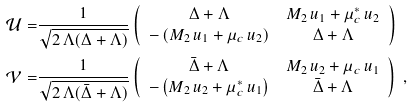<formula> <loc_0><loc_0><loc_500><loc_500>\mathcal { U } = & \frac { 1 } { \sqrt { 2 \, \Lambda ( \Delta + \Lambda ) } } \left ( \begin{array} { c c } \Delta + \Lambda & M _ { 2 } \, u _ { 1 } + \mu ^ { * } _ { c } \, u _ { 2 } \\ - \left ( M _ { 2 } \, u _ { 1 } + \mu _ { c } \, u _ { 2 } \right ) & \Delta + \Lambda \end{array} \right ) \\ \mathcal { V } = & \frac { 1 } { \sqrt { 2 \, \Lambda ( \bar { \Delta } + \Lambda ) } } \left ( \begin{array} { c c } \bar { \Delta } + \Lambda & M _ { 2 } \, u _ { 2 } + \mu _ { c } \, u _ { 1 } \\ - \left ( M _ { 2 } \, u _ { 2 } + \mu ^ { * } _ { c } \, u _ { 1 } \right ) & \bar { \Delta } + \Lambda \end{array} \right ) \ ,</formula> 